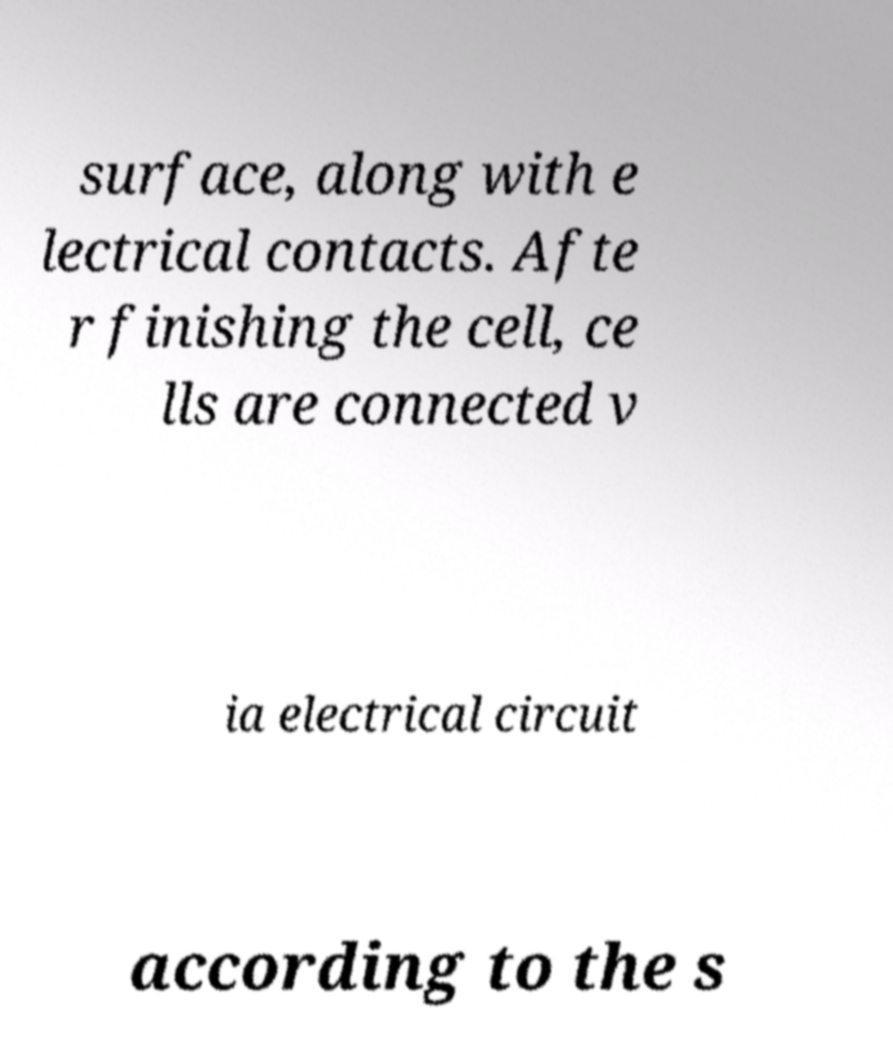Could you extract and type out the text from this image? surface, along with e lectrical contacts. Afte r finishing the cell, ce lls are connected v ia electrical circuit according to the s 